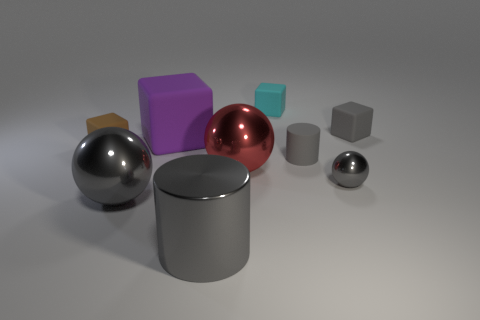Subtract all red cubes. Subtract all brown cylinders. How many cubes are left? 4 Subtract all balls. How many objects are left? 6 Add 6 large purple matte things. How many large purple matte things are left? 7 Add 8 large green metal balls. How many large green metal balls exist? 8 Subtract 0 green spheres. How many objects are left? 9 Subtract all metal cylinders. Subtract all large gray shiny things. How many objects are left? 6 